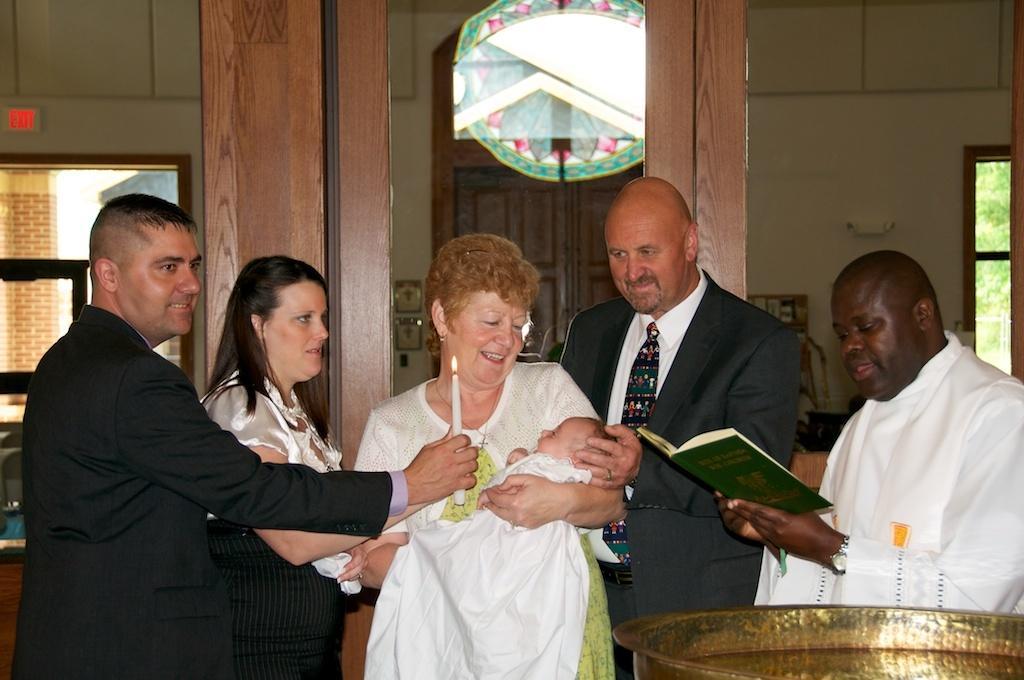Can you describe this image briefly? In this image there are five persons standing , a person carrying a baby, a person holding a book, a person holding a candle, and in the background there are windows, door. 